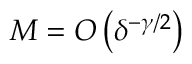Convert formula to latex. <formula><loc_0><loc_0><loc_500><loc_500>M = O \left ( \delta ^ { - \gamma / 2 } \right )</formula> 